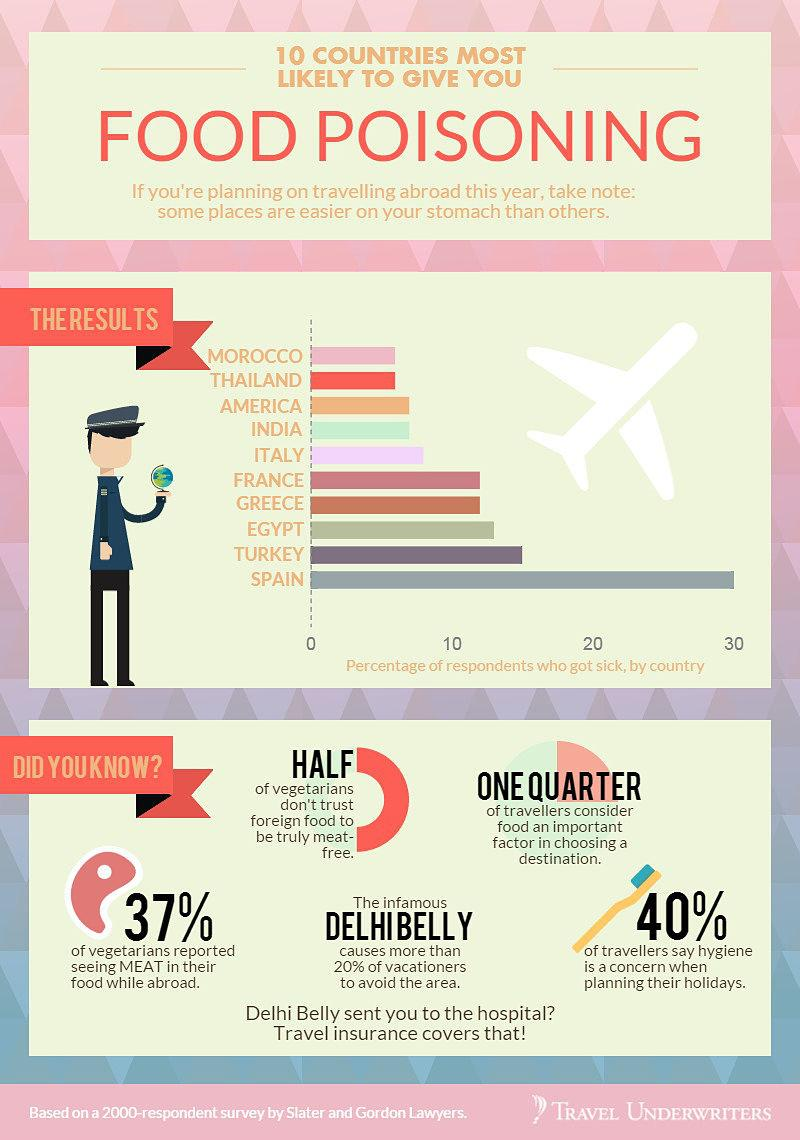Indicate a few pertinent items in this graphic. Delhibelly is linked to India. The color of the airplane is white. It is estimated that approximately 50% of foreigners do not trust foreign food to be truly meat-free. Other than Greece, several countries have reported food poisoning cases in the range of 10-20, including France, Egypt, and Turkey. When planning their holidays, the presence of a toothbrush indicates a concern for hygiene. 